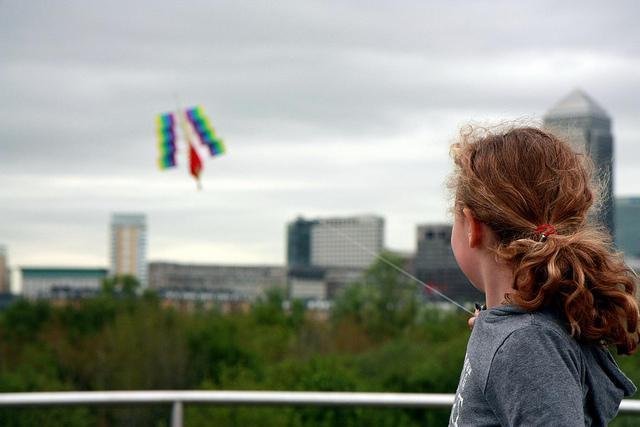How many hair items are in the girls hair?
Give a very brief answer. 1. How many animals?
Give a very brief answer. 0. 